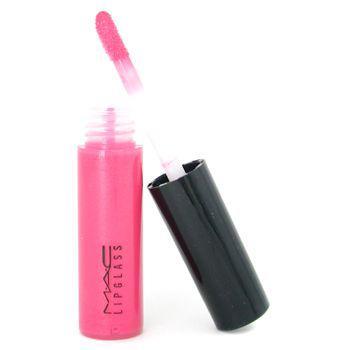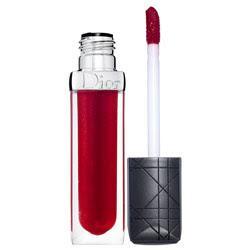The first image is the image on the left, the second image is the image on the right. Given the left and right images, does the statement "There is at least one lip gloss applicator out of the tube." hold true? Answer yes or no. Yes. 